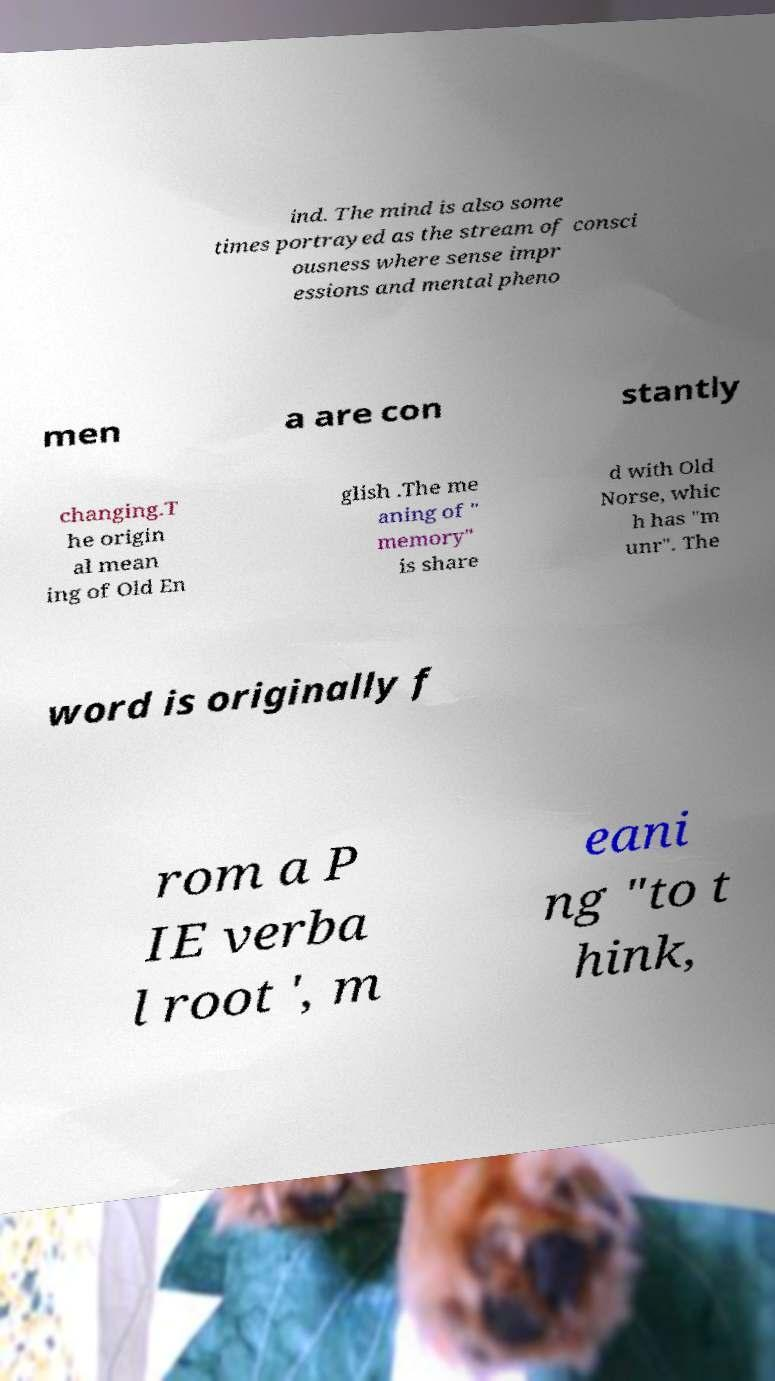For documentation purposes, I need the text within this image transcribed. Could you provide that? ind. The mind is also some times portrayed as the stream of consci ousness where sense impr essions and mental pheno men a are con stantly changing.T he origin al mean ing of Old En glish .The me aning of " memory" is share d with Old Norse, whic h has "m unr". The word is originally f rom a P IE verba l root ', m eani ng "to t hink, 